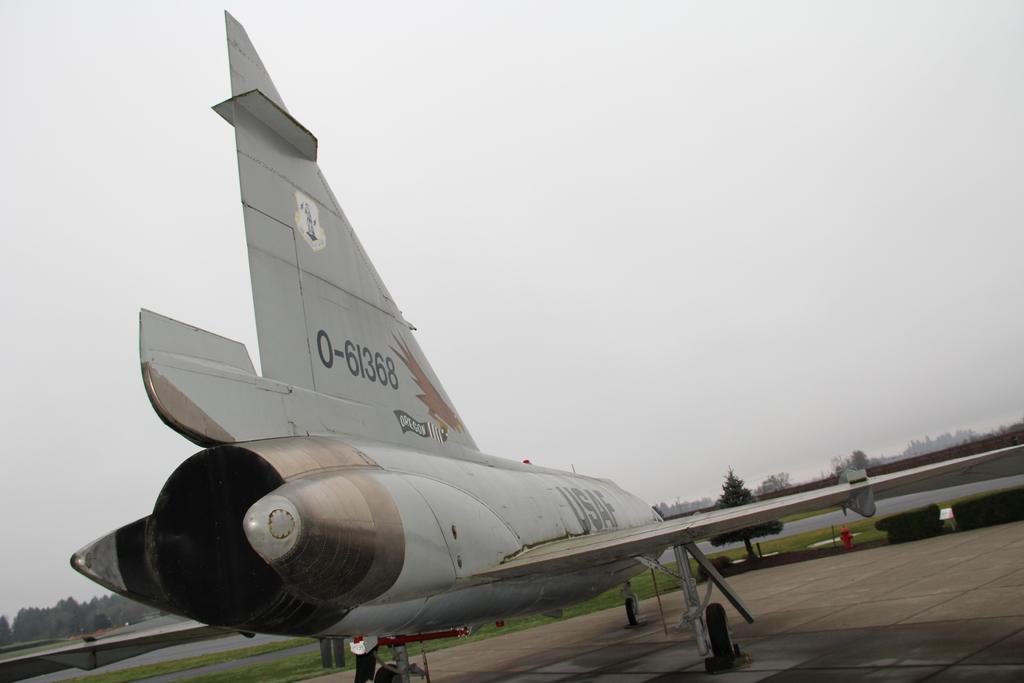What number code is on the plane?
Offer a very short reply. 0-61368. What branch of military is written on the body of the jet?
Your answer should be compact. Usaf. 